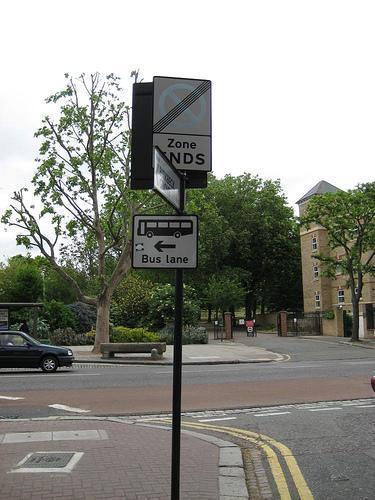How many signs on the pole?
Give a very brief answer. 4. How many signs feature arrows?
Give a very brief answer. 1. 